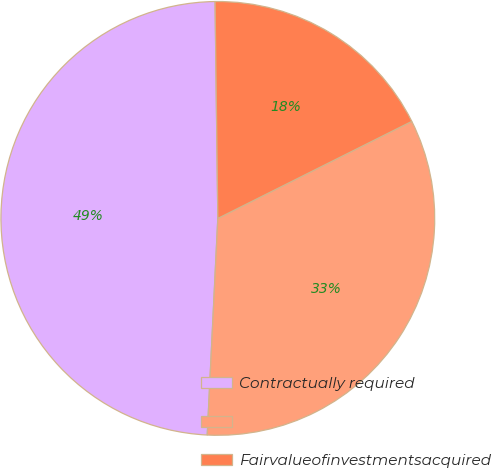Convert chart. <chart><loc_0><loc_0><loc_500><loc_500><pie_chart><fcel>Contractually required<fcel>Unnamed: 1<fcel>Fairvalueofinvestmentsacquired<nl><fcel>49.02%<fcel>33.16%<fcel>17.82%<nl></chart> 